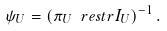Convert formula to latex. <formula><loc_0><loc_0><loc_500><loc_500>\psi _ { U } = \left ( \pi _ { U } \ r e s t r I _ { U } \right ) ^ { - 1 } .</formula> 